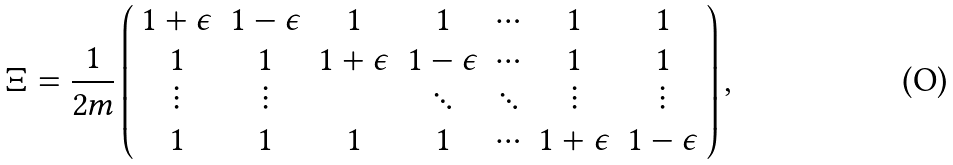Convert formula to latex. <formula><loc_0><loc_0><loc_500><loc_500>\Xi = \frac { 1 } { 2 m } \left ( \begin{array} { c c c c c c c } 1 + \epsilon & 1 - \epsilon & 1 & 1 & \cdots & 1 & 1 \\ 1 & 1 & 1 + \epsilon & 1 - \epsilon & \cdots & 1 & 1 \\ \vdots & \vdots & & \ddots & \ddots & \vdots & \vdots \\ 1 & 1 & 1 & 1 & \cdots & 1 + \epsilon & 1 - \epsilon \\ \end{array} \right ) ,</formula> 